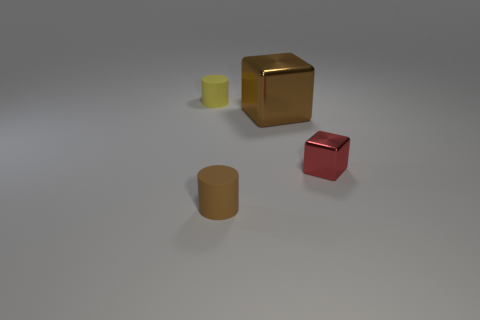Add 3 small green rubber cylinders. How many objects exist? 7 Subtract 2 cubes. How many cubes are left? 0 Subtract all brown cubes. How many cubes are left? 1 Add 3 brown rubber objects. How many brown rubber objects are left? 4 Add 4 big brown metal objects. How many big brown metal objects exist? 5 Subtract 1 red cubes. How many objects are left? 3 Subtract all purple cubes. Subtract all purple spheres. How many cubes are left? 2 Subtract all small yellow cylinders. Subtract all brown cylinders. How many objects are left? 2 